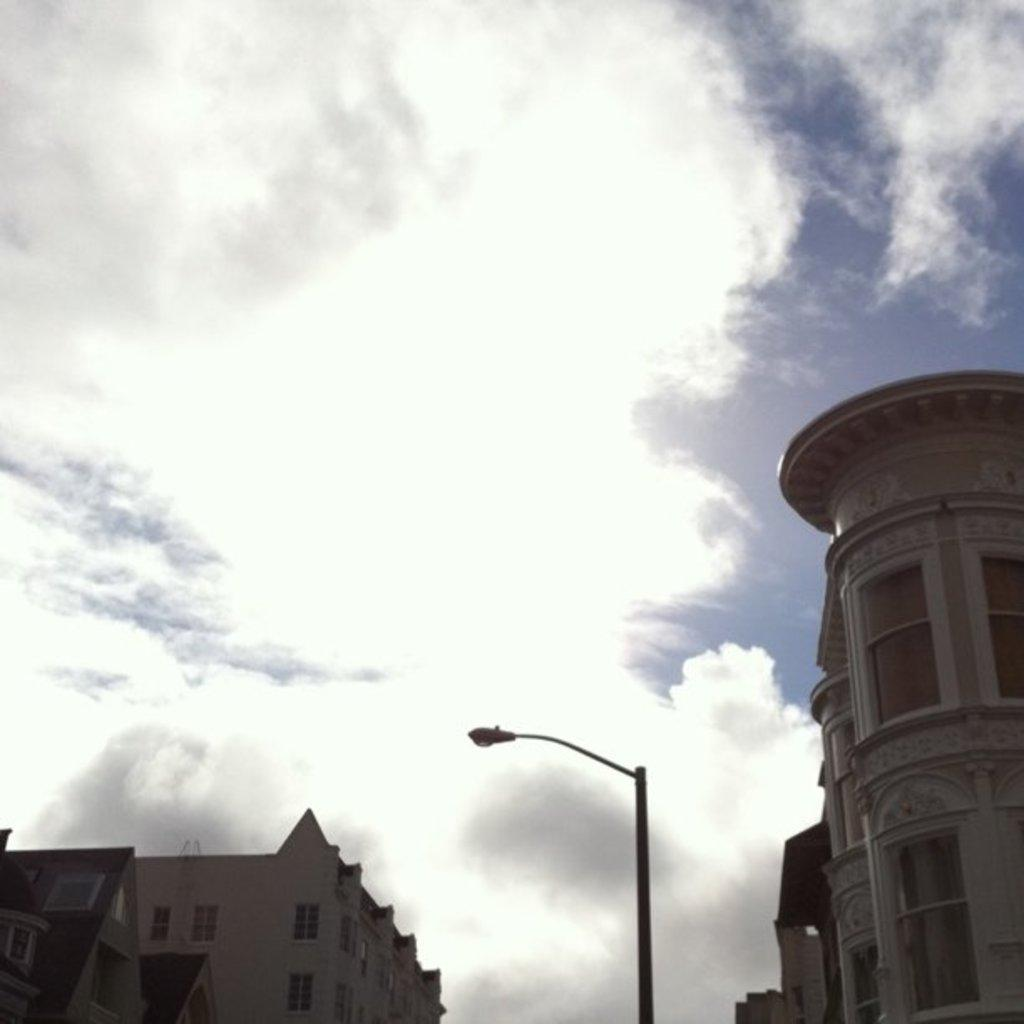What type of structures are visible in the image? There are buildings with windows in the image. What other object can be seen on the street in the image? There is a street light with a pole in the image. What is visible in the background of the image? The sky is visible in the background of the image. What can be observed in the sky? Clouds are present in the sky. How many cent can be seen on the street in the image? There are no cent visible in the image. 